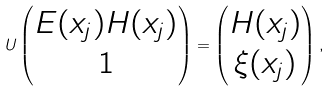Convert formula to latex. <formula><loc_0><loc_0><loc_500><loc_500>U \begin{pmatrix} E ( x _ { j } ) H ( x _ { j } ) \\ 1 \end{pmatrix} = \begin{pmatrix} H ( x _ { j } ) \\ \xi ( x _ { j } ) \end{pmatrix} ,</formula> 